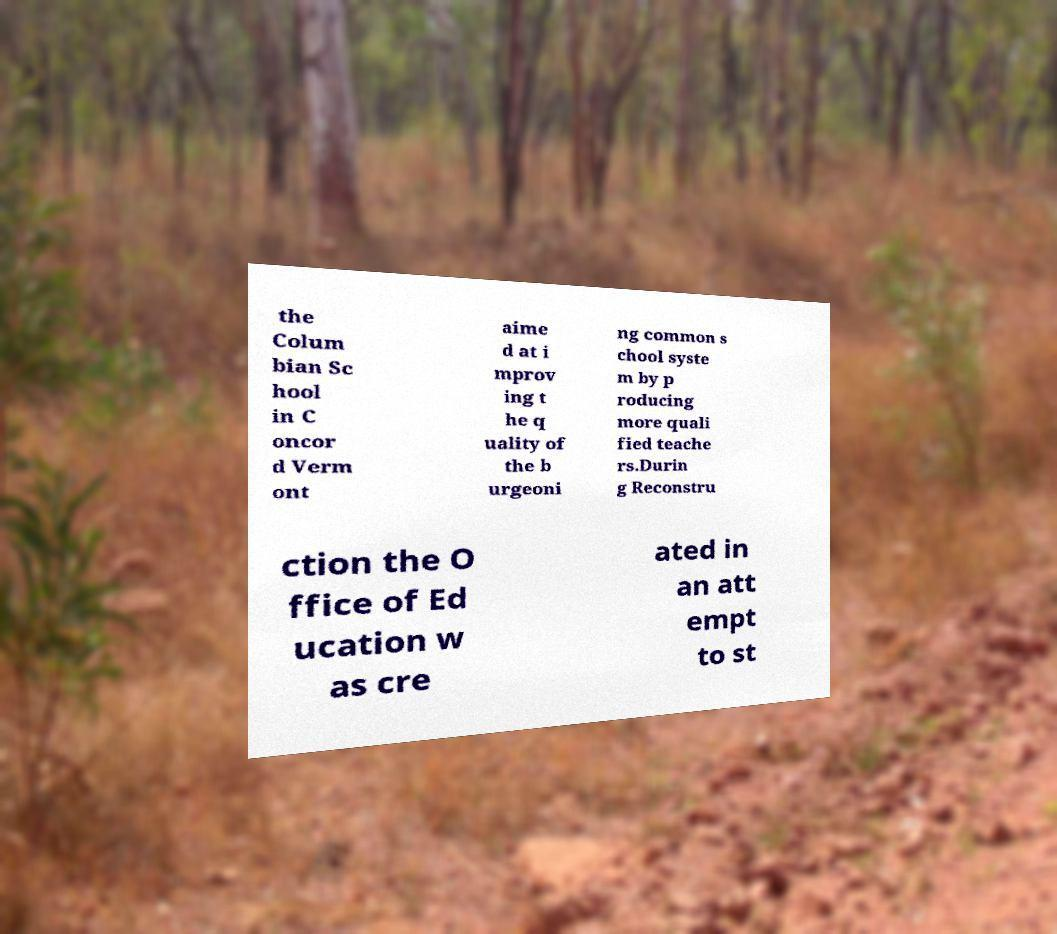I need the written content from this picture converted into text. Can you do that? the Colum bian Sc hool in C oncor d Verm ont aime d at i mprov ing t he q uality of the b urgeoni ng common s chool syste m by p roducing more quali fied teache rs.Durin g Reconstru ction the O ffice of Ed ucation w as cre ated in an att empt to st 